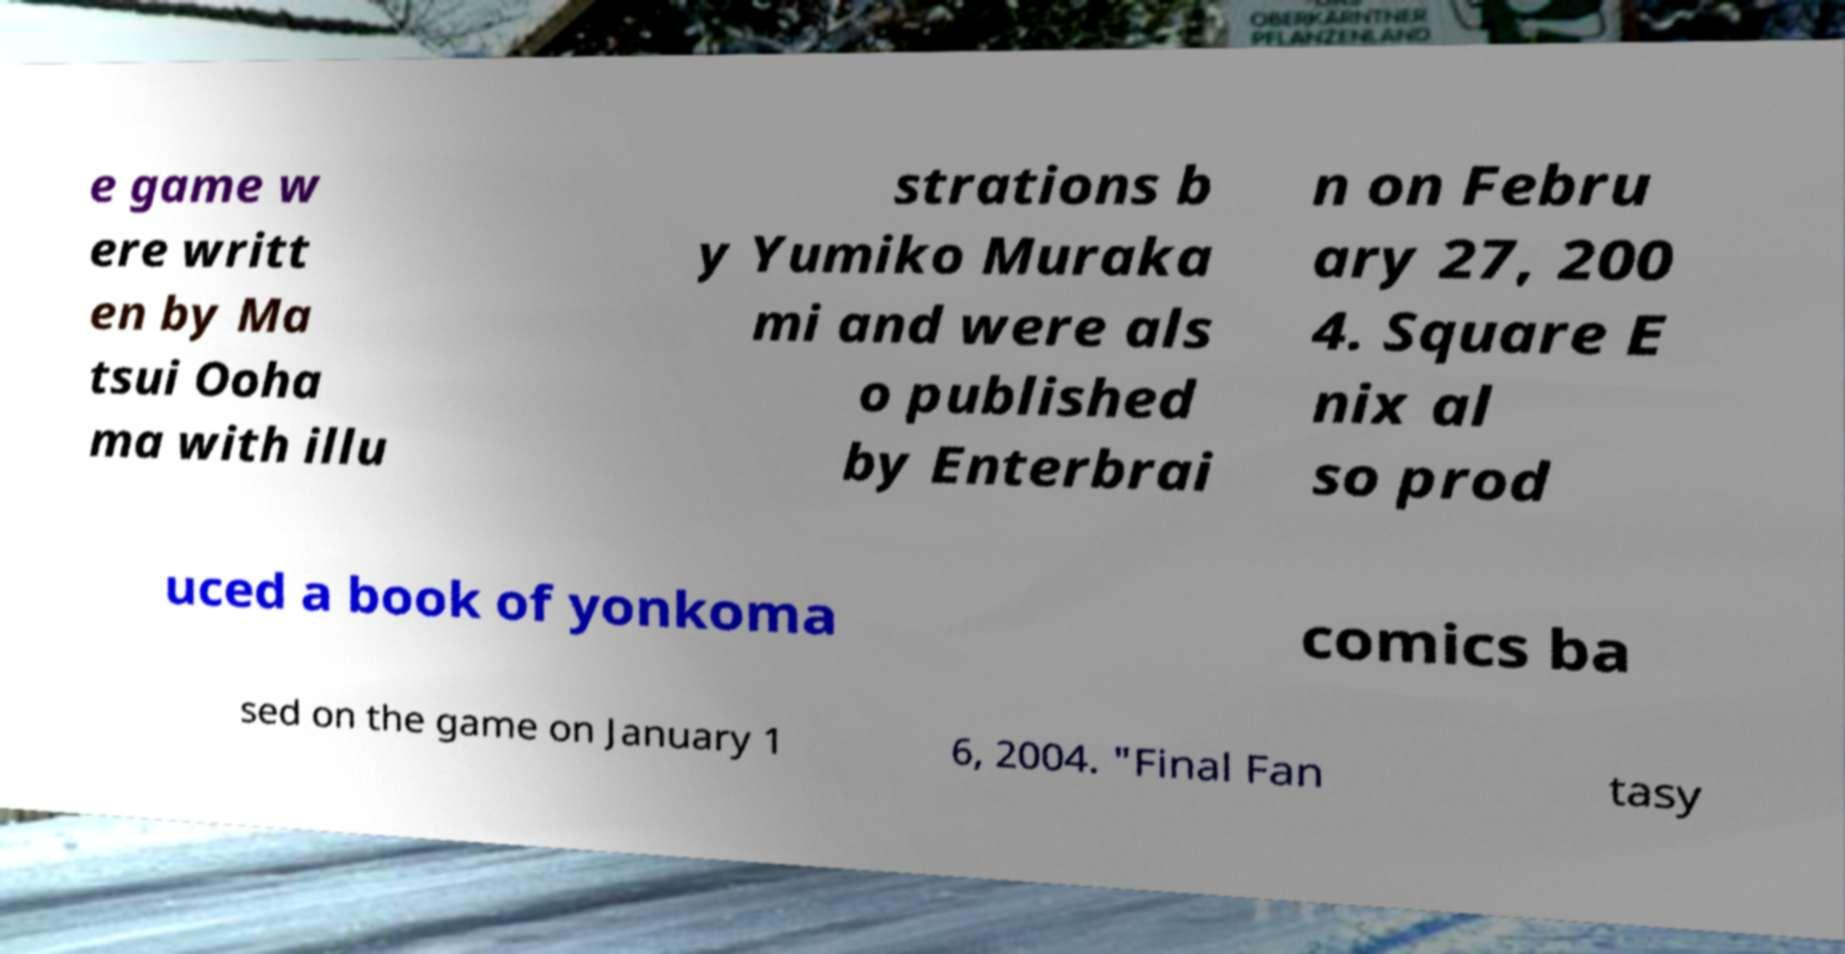I need the written content from this picture converted into text. Can you do that? e game w ere writt en by Ma tsui Ooha ma with illu strations b y Yumiko Muraka mi and were als o published by Enterbrai n on Febru ary 27, 200 4. Square E nix al so prod uced a book of yonkoma comics ba sed on the game on January 1 6, 2004. "Final Fan tasy 